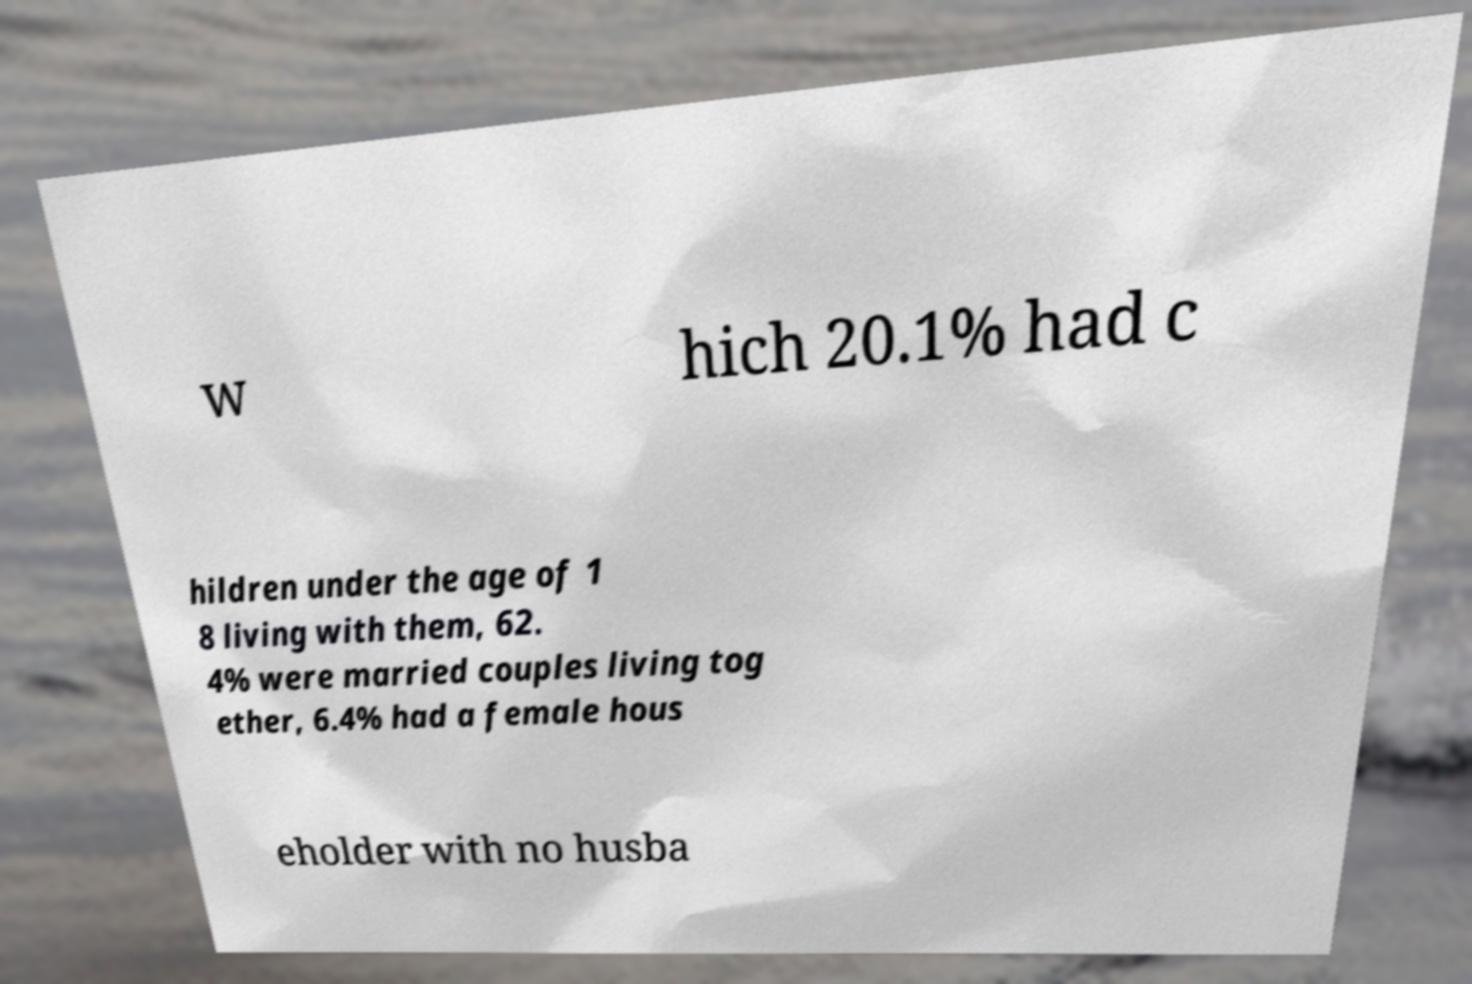There's text embedded in this image that I need extracted. Can you transcribe it verbatim? w hich 20.1% had c hildren under the age of 1 8 living with them, 62. 4% were married couples living tog ether, 6.4% had a female hous eholder with no husba 